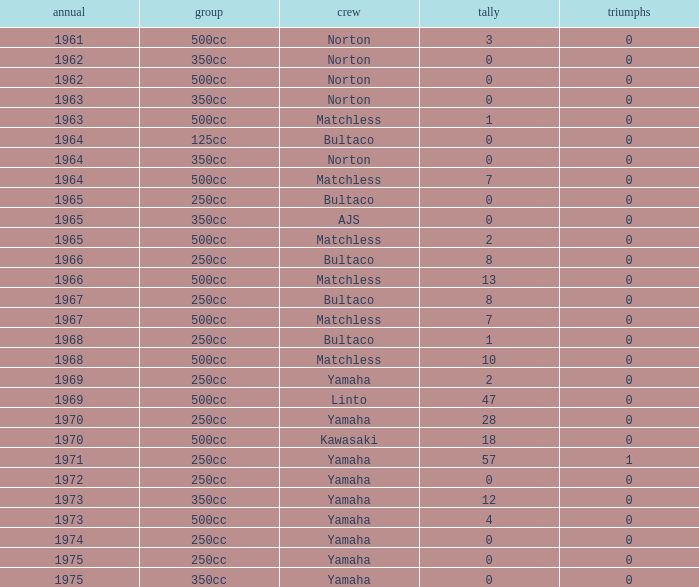What is the average wins in 250cc class for Bultaco with 8 points later than 1966? 0.0. 